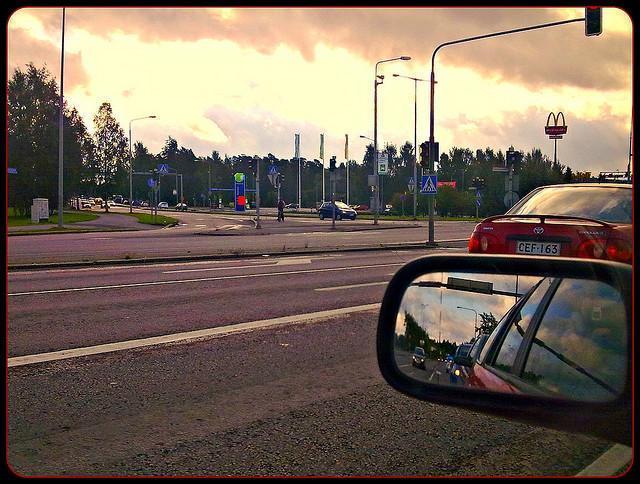How many cars can you see?
Give a very brief answer. 2. 